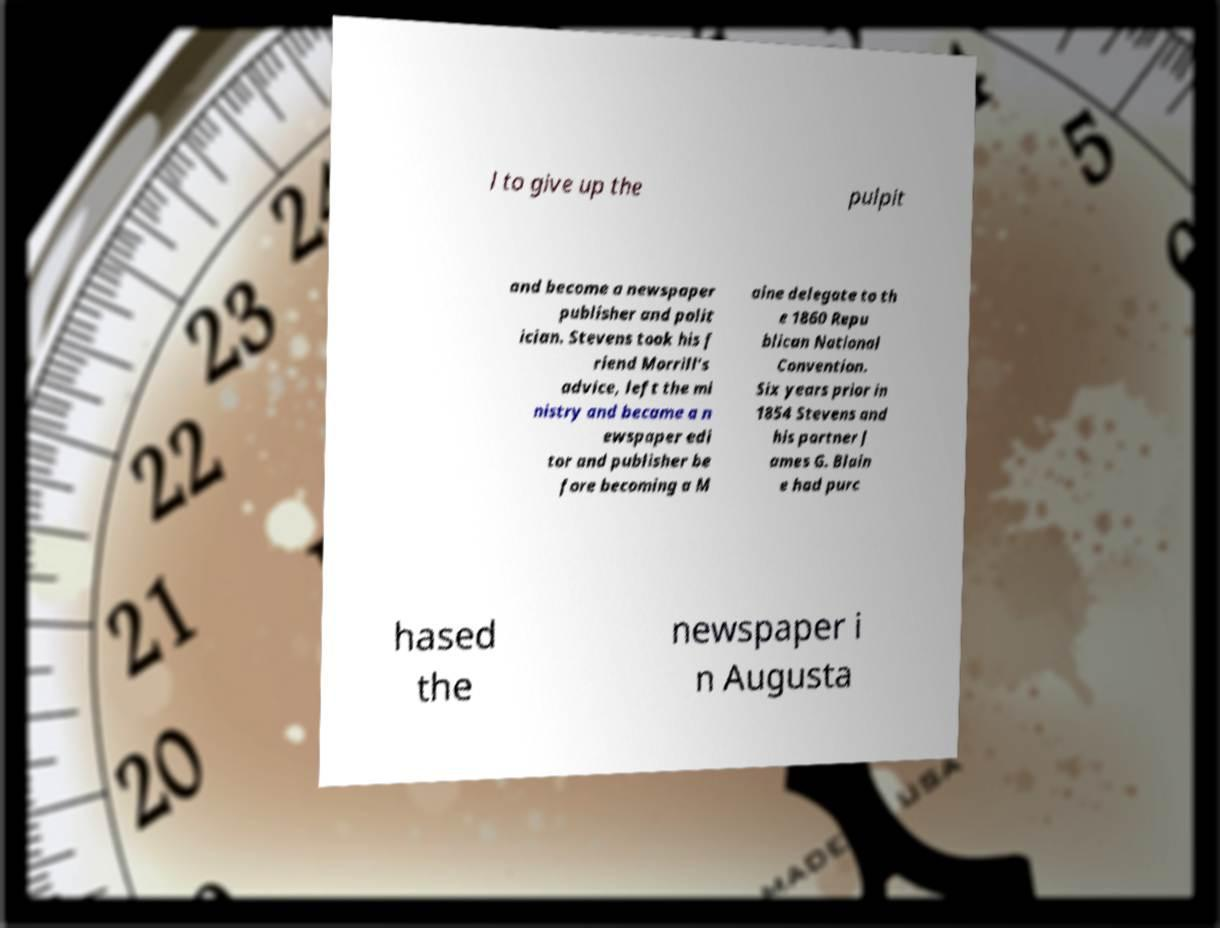There's text embedded in this image that I need extracted. Can you transcribe it verbatim? l to give up the pulpit and become a newspaper publisher and polit ician. Stevens took his f riend Morrill's advice, left the mi nistry and became a n ewspaper edi tor and publisher be fore becoming a M aine delegate to th e 1860 Repu blican National Convention. Six years prior in 1854 Stevens and his partner J ames G. Blain e had purc hased the newspaper i n Augusta 